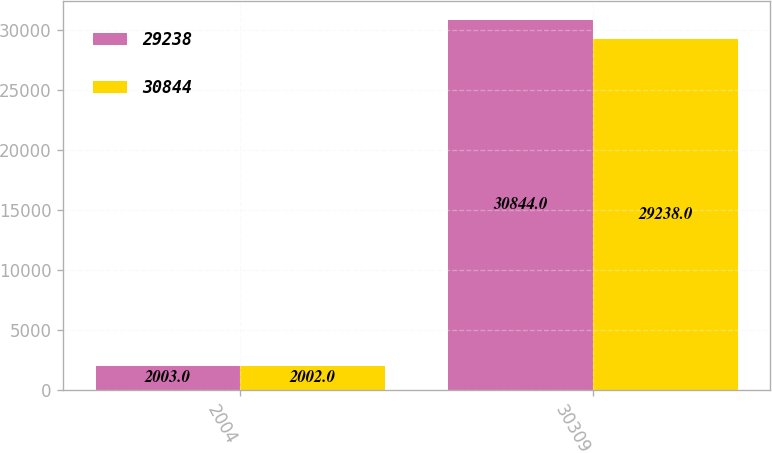<chart> <loc_0><loc_0><loc_500><loc_500><stacked_bar_chart><ecel><fcel>2004<fcel>30309<nl><fcel>29238<fcel>2003<fcel>30844<nl><fcel>30844<fcel>2002<fcel>29238<nl></chart> 